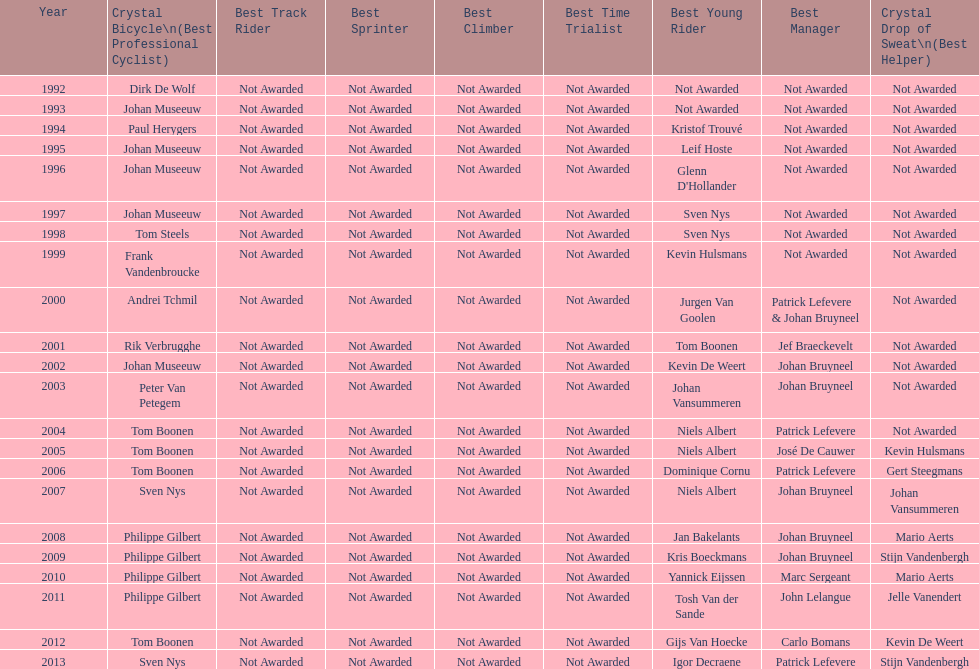Write the full table. {'header': ['Year', 'Crystal Bicycle\\n(Best Professional Cyclist)', 'Best Track Rider', 'Best Sprinter', 'Best Climber', 'Best Time Trialist', 'Best Young Rider', 'Best Manager', 'Crystal Drop of Sweat\\n(Best Helper)'], 'rows': [['1992', 'Dirk De Wolf', 'Not Awarded', 'Not Awarded', 'Not Awarded', 'Not Awarded', 'Not Awarded', 'Not Awarded', 'Not Awarded'], ['1993', 'Johan Museeuw', 'Not Awarded', 'Not Awarded', 'Not Awarded', 'Not Awarded', 'Not Awarded', 'Not Awarded', 'Not Awarded'], ['1994', 'Paul Herygers', 'Not Awarded', 'Not Awarded', 'Not Awarded', 'Not Awarded', 'Kristof Trouvé', 'Not Awarded', 'Not Awarded'], ['1995', 'Johan Museeuw', 'Not Awarded', 'Not Awarded', 'Not Awarded', 'Not Awarded', 'Leif Hoste', 'Not Awarded', 'Not Awarded'], ['1996', 'Johan Museeuw', 'Not Awarded', 'Not Awarded', 'Not Awarded', 'Not Awarded', "Glenn D'Hollander", 'Not Awarded', 'Not Awarded'], ['1997', 'Johan Museeuw', 'Not Awarded', 'Not Awarded', 'Not Awarded', 'Not Awarded', 'Sven Nys', 'Not Awarded', 'Not Awarded'], ['1998', 'Tom Steels', 'Not Awarded', 'Not Awarded', 'Not Awarded', 'Not Awarded', 'Sven Nys', 'Not Awarded', 'Not Awarded'], ['1999', 'Frank Vandenbroucke', 'Not Awarded', 'Not Awarded', 'Not Awarded', 'Not Awarded', 'Kevin Hulsmans', 'Not Awarded', 'Not Awarded'], ['2000', 'Andrei Tchmil', 'Not Awarded', 'Not Awarded', 'Not Awarded', 'Not Awarded', 'Jurgen Van Goolen', 'Patrick Lefevere & Johan Bruyneel', 'Not Awarded'], ['2001', 'Rik Verbrugghe', 'Not Awarded', 'Not Awarded', 'Not Awarded', 'Not Awarded', 'Tom Boonen', 'Jef Braeckevelt', 'Not Awarded'], ['2002', 'Johan Museeuw', 'Not Awarded', 'Not Awarded', 'Not Awarded', 'Not Awarded', 'Kevin De Weert', 'Johan Bruyneel', 'Not Awarded'], ['2003', 'Peter Van Petegem', 'Not Awarded', 'Not Awarded', 'Not Awarded', 'Not Awarded', 'Johan Vansummeren', 'Johan Bruyneel', 'Not Awarded'], ['2004', 'Tom Boonen', 'Not Awarded', 'Not Awarded', 'Not Awarded', 'Not Awarded', 'Niels Albert', 'Patrick Lefevere', 'Not Awarded'], ['2005', 'Tom Boonen', 'Not Awarded', 'Not Awarded', 'Not Awarded', 'Not Awarded', 'Niels Albert', 'José De Cauwer', 'Kevin Hulsmans'], ['2006', 'Tom Boonen', 'Not Awarded', 'Not Awarded', 'Not Awarded', 'Not Awarded', 'Dominique Cornu', 'Patrick Lefevere', 'Gert Steegmans'], ['2007', 'Sven Nys', 'Not Awarded', 'Not Awarded', 'Not Awarded', 'Not Awarded', 'Niels Albert', 'Johan Bruyneel', 'Johan Vansummeren'], ['2008', 'Philippe Gilbert', 'Not Awarded', 'Not Awarded', 'Not Awarded', 'Not Awarded', 'Jan Bakelants', 'Johan Bruyneel', 'Mario Aerts'], ['2009', 'Philippe Gilbert', 'Not Awarded', 'Not Awarded', 'Not Awarded', 'Not Awarded', 'Kris Boeckmans', 'Johan Bruyneel', 'Stijn Vandenbergh'], ['2010', 'Philippe Gilbert', 'Not Awarded', 'Not Awarded', 'Not Awarded', 'Not Awarded', 'Yannick Eijssen', 'Marc Sergeant', 'Mario Aerts'], ['2011', 'Philippe Gilbert', 'Not Awarded', 'Not Awarded', 'Not Awarded', 'Not Awarded', 'Tosh Van der Sande', 'John Lelangue', 'Jelle Vanendert'], ['2012', 'Tom Boonen', 'Not Awarded', 'Not Awarded', 'Not Awarded', 'Not Awarded', 'Gijs Van Hoecke', 'Carlo Bomans', 'Kevin De Weert'], ['2013', 'Sven Nys', 'Not Awarded', 'Not Awarded', 'Not Awarded', 'Not Awarded', 'Igor Decraene', 'Patrick Lefevere', 'Stijn Vandenbergh']]} Between boonen and nys, who previously secured the crystal bicycle victory? Tom Boonen. 